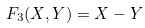Convert formula to latex. <formula><loc_0><loc_0><loc_500><loc_500>F _ { 3 } ( X , Y ) = X - Y</formula> 